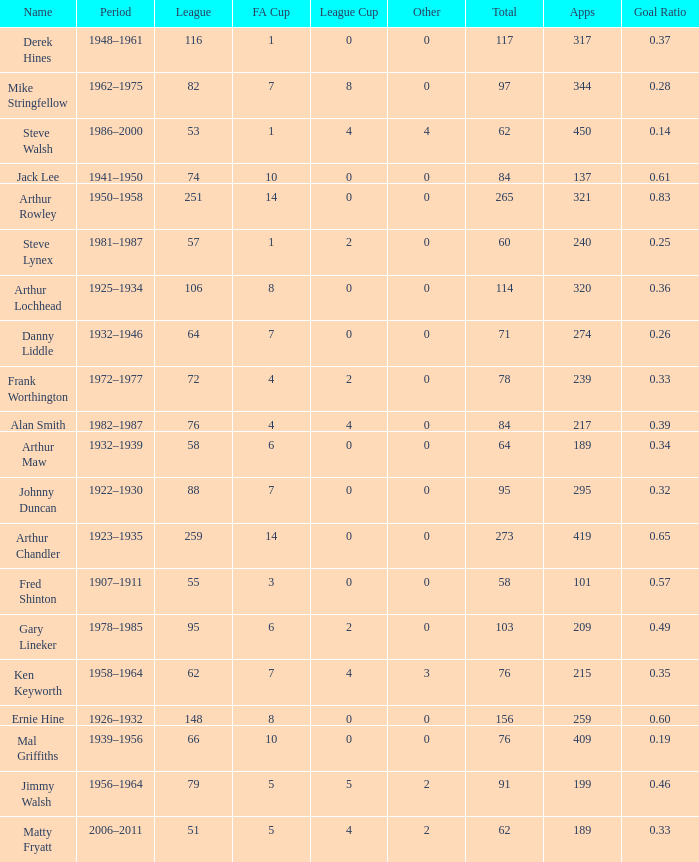What's the Highest Goal Ratio with a League of 88 and an FA Cup less than 7? None. 